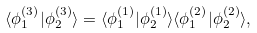Convert formula to latex. <formula><loc_0><loc_0><loc_500><loc_500>\langle \phi _ { 1 } ^ { ( 3 ) } | \phi _ { 2 } ^ { ( 3 ) } \rangle = \langle \phi _ { 1 } ^ { ( 1 ) } | \phi _ { 2 } ^ { ( 1 ) } \rangle \langle \phi _ { 1 } ^ { ( 2 ) } | \phi _ { 2 } ^ { ( 2 ) } \rangle ,</formula> 